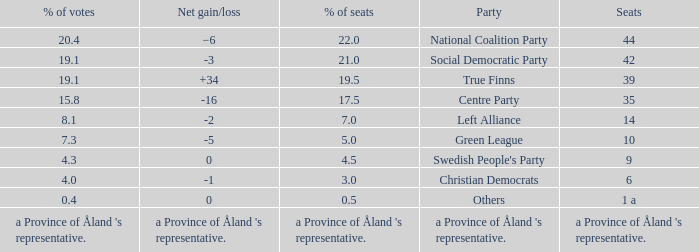Which party has a net gain/loss of -2? Left Alliance. 